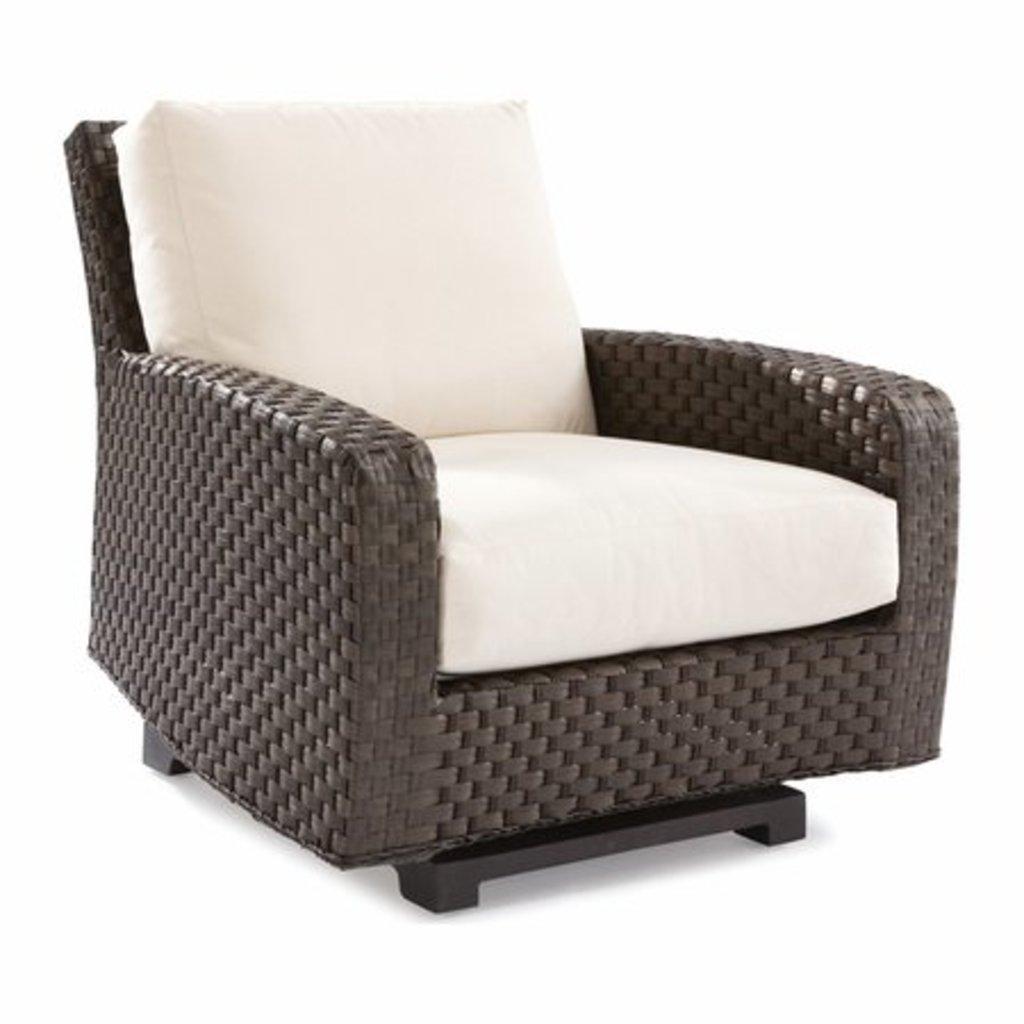Could you give a brief overview of what you see in this image? In this picture there is a brown color chair and there are cream colored pillows on the chair. At the back there is a white background. 